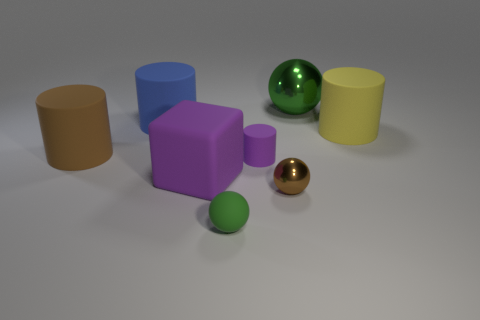Subtract 1 cylinders. How many cylinders are left? 3 Subtract all green cylinders. Subtract all blue balls. How many cylinders are left? 4 Add 2 big cyan shiny cubes. How many objects exist? 10 Subtract all balls. How many objects are left? 5 Subtract all green rubber objects. Subtract all purple cylinders. How many objects are left? 6 Add 1 tiny purple matte things. How many tiny purple matte things are left? 2 Add 4 big cyan cylinders. How many big cyan cylinders exist? 4 Subtract 0 yellow cubes. How many objects are left? 8 